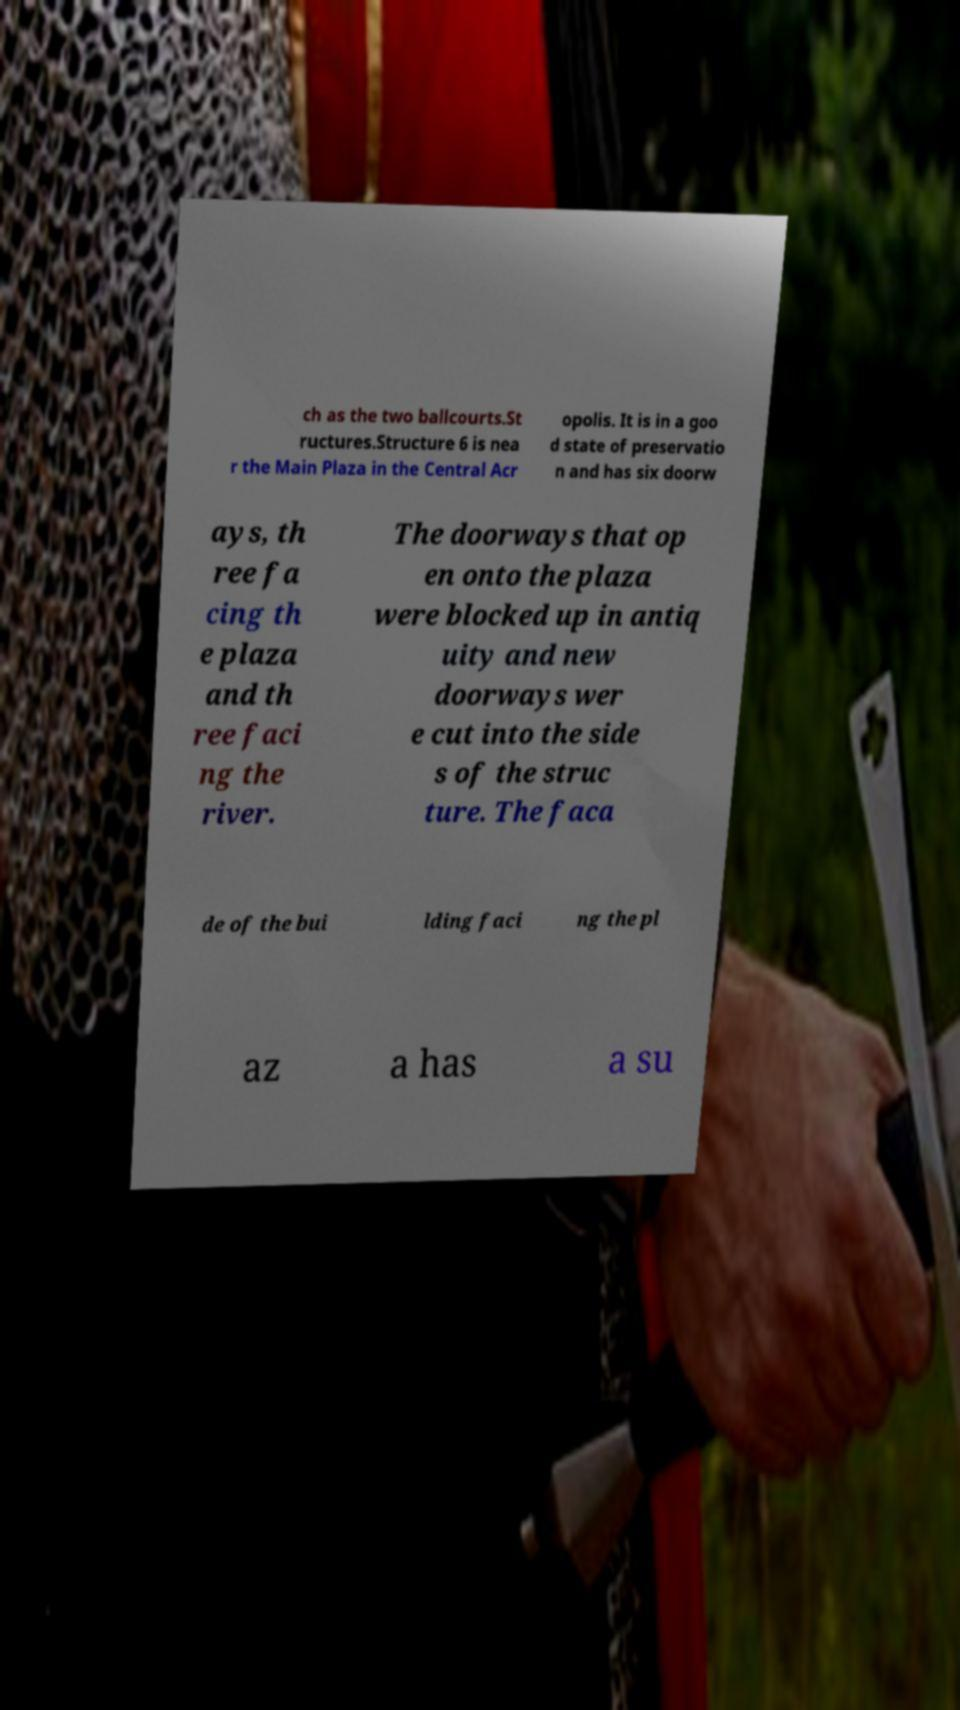There's text embedded in this image that I need extracted. Can you transcribe it verbatim? ch as the two ballcourts.St ructures.Structure 6 is nea r the Main Plaza in the Central Acr opolis. It is in a goo d state of preservatio n and has six doorw ays, th ree fa cing th e plaza and th ree faci ng the river. The doorways that op en onto the plaza were blocked up in antiq uity and new doorways wer e cut into the side s of the struc ture. The faca de of the bui lding faci ng the pl az a has a su 